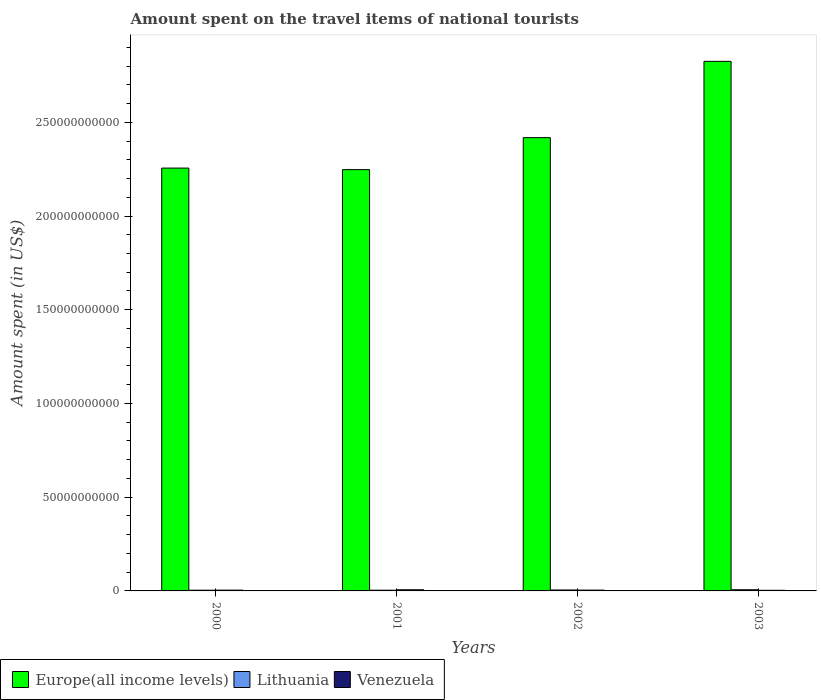How many bars are there on the 2nd tick from the left?
Provide a succinct answer. 3. How many bars are there on the 2nd tick from the right?
Your answer should be compact. 3. What is the label of the 1st group of bars from the left?
Your answer should be compact. 2000. What is the amount spent on the travel items of national tourists in Venezuela in 2002?
Ensure brevity in your answer.  4.34e+08. Across all years, what is the maximum amount spent on the travel items of national tourists in Europe(all income levels)?
Make the answer very short. 2.83e+11. Across all years, what is the minimum amount spent on the travel items of national tourists in Europe(all income levels)?
Provide a succinct answer. 2.25e+11. In which year was the amount spent on the travel items of national tourists in Europe(all income levels) maximum?
Keep it short and to the point. 2003. What is the total amount spent on the travel items of national tourists in Venezuela in the graph?
Provide a succinct answer. 1.80e+09. What is the difference between the amount spent on the travel items of national tourists in Europe(all income levels) in 2001 and that in 2002?
Ensure brevity in your answer.  -1.71e+1. What is the difference between the amount spent on the travel items of national tourists in Lithuania in 2001 and the amount spent on the travel items of national tourists in Venezuela in 2002?
Offer a very short reply. -5.10e+07. What is the average amount spent on the travel items of national tourists in Europe(all income levels) per year?
Make the answer very short. 2.44e+11. In the year 2000, what is the difference between the amount spent on the travel items of national tourists in Lithuania and amount spent on the travel items of national tourists in Europe(all income levels)?
Your response must be concise. -2.25e+11. What is the ratio of the amount spent on the travel items of national tourists in Venezuela in 2002 to that in 2003?
Provide a succinct answer. 1.31. Is the amount spent on the travel items of national tourists in Lithuania in 2001 less than that in 2002?
Give a very brief answer. Yes. Is the difference between the amount spent on the travel items of national tourists in Lithuania in 2002 and 2003 greater than the difference between the amount spent on the travel items of national tourists in Europe(all income levels) in 2002 and 2003?
Ensure brevity in your answer.  Yes. What is the difference between the highest and the second highest amount spent on the travel items of national tourists in Lithuania?
Your answer should be compact. 1.33e+08. What is the difference between the highest and the lowest amount spent on the travel items of national tourists in Europe(all income levels)?
Make the answer very short. 5.78e+1. Is the sum of the amount spent on the travel items of national tourists in Lithuania in 2001 and 2003 greater than the maximum amount spent on the travel items of national tourists in Europe(all income levels) across all years?
Your response must be concise. No. What does the 3rd bar from the left in 2000 represents?
Provide a succinct answer. Venezuela. What does the 3rd bar from the right in 2000 represents?
Keep it short and to the point. Europe(all income levels). How many bars are there?
Offer a very short reply. 12. How many years are there in the graph?
Provide a succinct answer. 4. Are the values on the major ticks of Y-axis written in scientific E-notation?
Keep it short and to the point. No. How many legend labels are there?
Your answer should be very brief. 3. What is the title of the graph?
Make the answer very short. Amount spent on the travel items of national tourists. Does "France" appear as one of the legend labels in the graph?
Your answer should be compact. No. What is the label or title of the X-axis?
Make the answer very short. Years. What is the label or title of the Y-axis?
Keep it short and to the point. Amount spent (in US$). What is the Amount spent (in US$) in Europe(all income levels) in 2000?
Offer a terse response. 2.26e+11. What is the Amount spent (in US$) of Lithuania in 2000?
Your answer should be very brief. 3.91e+08. What is the Amount spent (in US$) of Venezuela in 2000?
Your answer should be compact. 4.23e+08. What is the Amount spent (in US$) in Europe(all income levels) in 2001?
Give a very brief answer. 2.25e+11. What is the Amount spent (in US$) of Lithuania in 2001?
Give a very brief answer. 3.83e+08. What is the Amount spent (in US$) of Venezuela in 2001?
Ensure brevity in your answer.  6.15e+08. What is the Amount spent (in US$) of Europe(all income levels) in 2002?
Offer a very short reply. 2.42e+11. What is the Amount spent (in US$) of Lithuania in 2002?
Offer a terse response. 5.05e+08. What is the Amount spent (in US$) of Venezuela in 2002?
Provide a succinct answer. 4.34e+08. What is the Amount spent (in US$) in Europe(all income levels) in 2003?
Give a very brief answer. 2.83e+11. What is the Amount spent (in US$) of Lithuania in 2003?
Make the answer very short. 6.38e+08. What is the Amount spent (in US$) of Venezuela in 2003?
Your answer should be compact. 3.31e+08. Across all years, what is the maximum Amount spent (in US$) in Europe(all income levels)?
Give a very brief answer. 2.83e+11. Across all years, what is the maximum Amount spent (in US$) in Lithuania?
Your answer should be very brief. 6.38e+08. Across all years, what is the maximum Amount spent (in US$) of Venezuela?
Make the answer very short. 6.15e+08. Across all years, what is the minimum Amount spent (in US$) in Europe(all income levels)?
Offer a terse response. 2.25e+11. Across all years, what is the minimum Amount spent (in US$) of Lithuania?
Ensure brevity in your answer.  3.83e+08. Across all years, what is the minimum Amount spent (in US$) in Venezuela?
Your answer should be very brief. 3.31e+08. What is the total Amount spent (in US$) of Europe(all income levels) in the graph?
Offer a terse response. 9.75e+11. What is the total Amount spent (in US$) of Lithuania in the graph?
Provide a short and direct response. 1.92e+09. What is the total Amount spent (in US$) in Venezuela in the graph?
Your answer should be compact. 1.80e+09. What is the difference between the Amount spent (in US$) of Europe(all income levels) in 2000 and that in 2001?
Ensure brevity in your answer.  8.29e+08. What is the difference between the Amount spent (in US$) in Lithuania in 2000 and that in 2001?
Your answer should be very brief. 8.00e+06. What is the difference between the Amount spent (in US$) of Venezuela in 2000 and that in 2001?
Offer a very short reply. -1.92e+08. What is the difference between the Amount spent (in US$) of Europe(all income levels) in 2000 and that in 2002?
Provide a short and direct response. -1.62e+1. What is the difference between the Amount spent (in US$) in Lithuania in 2000 and that in 2002?
Offer a terse response. -1.14e+08. What is the difference between the Amount spent (in US$) of Venezuela in 2000 and that in 2002?
Give a very brief answer. -1.10e+07. What is the difference between the Amount spent (in US$) in Europe(all income levels) in 2000 and that in 2003?
Make the answer very short. -5.69e+1. What is the difference between the Amount spent (in US$) of Lithuania in 2000 and that in 2003?
Offer a very short reply. -2.47e+08. What is the difference between the Amount spent (in US$) in Venezuela in 2000 and that in 2003?
Your response must be concise. 9.20e+07. What is the difference between the Amount spent (in US$) in Europe(all income levels) in 2001 and that in 2002?
Keep it short and to the point. -1.71e+1. What is the difference between the Amount spent (in US$) in Lithuania in 2001 and that in 2002?
Give a very brief answer. -1.22e+08. What is the difference between the Amount spent (in US$) of Venezuela in 2001 and that in 2002?
Provide a short and direct response. 1.81e+08. What is the difference between the Amount spent (in US$) of Europe(all income levels) in 2001 and that in 2003?
Your answer should be compact. -5.78e+1. What is the difference between the Amount spent (in US$) of Lithuania in 2001 and that in 2003?
Your answer should be compact. -2.55e+08. What is the difference between the Amount spent (in US$) in Venezuela in 2001 and that in 2003?
Offer a terse response. 2.84e+08. What is the difference between the Amount spent (in US$) in Europe(all income levels) in 2002 and that in 2003?
Provide a short and direct response. -4.07e+1. What is the difference between the Amount spent (in US$) in Lithuania in 2002 and that in 2003?
Your response must be concise. -1.33e+08. What is the difference between the Amount spent (in US$) in Venezuela in 2002 and that in 2003?
Provide a succinct answer. 1.03e+08. What is the difference between the Amount spent (in US$) of Europe(all income levels) in 2000 and the Amount spent (in US$) of Lithuania in 2001?
Offer a very short reply. 2.25e+11. What is the difference between the Amount spent (in US$) of Europe(all income levels) in 2000 and the Amount spent (in US$) of Venezuela in 2001?
Give a very brief answer. 2.25e+11. What is the difference between the Amount spent (in US$) in Lithuania in 2000 and the Amount spent (in US$) in Venezuela in 2001?
Give a very brief answer. -2.24e+08. What is the difference between the Amount spent (in US$) in Europe(all income levels) in 2000 and the Amount spent (in US$) in Lithuania in 2002?
Give a very brief answer. 2.25e+11. What is the difference between the Amount spent (in US$) in Europe(all income levels) in 2000 and the Amount spent (in US$) in Venezuela in 2002?
Provide a succinct answer. 2.25e+11. What is the difference between the Amount spent (in US$) in Lithuania in 2000 and the Amount spent (in US$) in Venezuela in 2002?
Provide a succinct answer. -4.30e+07. What is the difference between the Amount spent (in US$) of Europe(all income levels) in 2000 and the Amount spent (in US$) of Lithuania in 2003?
Make the answer very short. 2.25e+11. What is the difference between the Amount spent (in US$) of Europe(all income levels) in 2000 and the Amount spent (in US$) of Venezuela in 2003?
Your answer should be very brief. 2.25e+11. What is the difference between the Amount spent (in US$) of Lithuania in 2000 and the Amount spent (in US$) of Venezuela in 2003?
Keep it short and to the point. 6.00e+07. What is the difference between the Amount spent (in US$) of Europe(all income levels) in 2001 and the Amount spent (in US$) of Lithuania in 2002?
Keep it short and to the point. 2.24e+11. What is the difference between the Amount spent (in US$) in Europe(all income levels) in 2001 and the Amount spent (in US$) in Venezuela in 2002?
Your answer should be very brief. 2.24e+11. What is the difference between the Amount spent (in US$) of Lithuania in 2001 and the Amount spent (in US$) of Venezuela in 2002?
Make the answer very short. -5.10e+07. What is the difference between the Amount spent (in US$) in Europe(all income levels) in 2001 and the Amount spent (in US$) in Lithuania in 2003?
Your answer should be very brief. 2.24e+11. What is the difference between the Amount spent (in US$) in Europe(all income levels) in 2001 and the Amount spent (in US$) in Venezuela in 2003?
Provide a short and direct response. 2.24e+11. What is the difference between the Amount spent (in US$) of Lithuania in 2001 and the Amount spent (in US$) of Venezuela in 2003?
Make the answer very short. 5.20e+07. What is the difference between the Amount spent (in US$) in Europe(all income levels) in 2002 and the Amount spent (in US$) in Lithuania in 2003?
Provide a succinct answer. 2.41e+11. What is the difference between the Amount spent (in US$) in Europe(all income levels) in 2002 and the Amount spent (in US$) in Venezuela in 2003?
Your response must be concise. 2.41e+11. What is the difference between the Amount spent (in US$) of Lithuania in 2002 and the Amount spent (in US$) of Venezuela in 2003?
Ensure brevity in your answer.  1.74e+08. What is the average Amount spent (in US$) in Europe(all income levels) per year?
Offer a very short reply. 2.44e+11. What is the average Amount spent (in US$) in Lithuania per year?
Your answer should be very brief. 4.79e+08. What is the average Amount spent (in US$) in Venezuela per year?
Provide a short and direct response. 4.51e+08. In the year 2000, what is the difference between the Amount spent (in US$) of Europe(all income levels) and Amount spent (in US$) of Lithuania?
Offer a terse response. 2.25e+11. In the year 2000, what is the difference between the Amount spent (in US$) of Europe(all income levels) and Amount spent (in US$) of Venezuela?
Your response must be concise. 2.25e+11. In the year 2000, what is the difference between the Amount spent (in US$) of Lithuania and Amount spent (in US$) of Venezuela?
Offer a very short reply. -3.20e+07. In the year 2001, what is the difference between the Amount spent (in US$) of Europe(all income levels) and Amount spent (in US$) of Lithuania?
Provide a succinct answer. 2.24e+11. In the year 2001, what is the difference between the Amount spent (in US$) of Europe(all income levels) and Amount spent (in US$) of Venezuela?
Provide a succinct answer. 2.24e+11. In the year 2001, what is the difference between the Amount spent (in US$) of Lithuania and Amount spent (in US$) of Venezuela?
Give a very brief answer. -2.32e+08. In the year 2002, what is the difference between the Amount spent (in US$) of Europe(all income levels) and Amount spent (in US$) of Lithuania?
Ensure brevity in your answer.  2.41e+11. In the year 2002, what is the difference between the Amount spent (in US$) of Europe(all income levels) and Amount spent (in US$) of Venezuela?
Your response must be concise. 2.41e+11. In the year 2002, what is the difference between the Amount spent (in US$) in Lithuania and Amount spent (in US$) in Venezuela?
Offer a very short reply. 7.10e+07. In the year 2003, what is the difference between the Amount spent (in US$) of Europe(all income levels) and Amount spent (in US$) of Lithuania?
Give a very brief answer. 2.82e+11. In the year 2003, what is the difference between the Amount spent (in US$) in Europe(all income levels) and Amount spent (in US$) in Venezuela?
Ensure brevity in your answer.  2.82e+11. In the year 2003, what is the difference between the Amount spent (in US$) in Lithuania and Amount spent (in US$) in Venezuela?
Your answer should be compact. 3.07e+08. What is the ratio of the Amount spent (in US$) in Europe(all income levels) in 2000 to that in 2001?
Your answer should be very brief. 1. What is the ratio of the Amount spent (in US$) of Lithuania in 2000 to that in 2001?
Offer a very short reply. 1.02. What is the ratio of the Amount spent (in US$) in Venezuela in 2000 to that in 2001?
Provide a short and direct response. 0.69. What is the ratio of the Amount spent (in US$) in Europe(all income levels) in 2000 to that in 2002?
Keep it short and to the point. 0.93. What is the ratio of the Amount spent (in US$) of Lithuania in 2000 to that in 2002?
Your answer should be very brief. 0.77. What is the ratio of the Amount spent (in US$) of Venezuela in 2000 to that in 2002?
Your answer should be very brief. 0.97. What is the ratio of the Amount spent (in US$) in Europe(all income levels) in 2000 to that in 2003?
Keep it short and to the point. 0.8. What is the ratio of the Amount spent (in US$) of Lithuania in 2000 to that in 2003?
Keep it short and to the point. 0.61. What is the ratio of the Amount spent (in US$) of Venezuela in 2000 to that in 2003?
Your response must be concise. 1.28. What is the ratio of the Amount spent (in US$) of Europe(all income levels) in 2001 to that in 2002?
Provide a succinct answer. 0.93. What is the ratio of the Amount spent (in US$) of Lithuania in 2001 to that in 2002?
Offer a very short reply. 0.76. What is the ratio of the Amount spent (in US$) in Venezuela in 2001 to that in 2002?
Your response must be concise. 1.42. What is the ratio of the Amount spent (in US$) in Europe(all income levels) in 2001 to that in 2003?
Your response must be concise. 0.8. What is the ratio of the Amount spent (in US$) in Lithuania in 2001 to that in 2003?
Keep it short and to the point. 0.6. What is the ratio of the Amount spent (in US$) in Venezuela in 2001 to that in 2003?
Your answer should be compact. 1.86. What is the ratio of the Amount spent (in US$) of Europe(all income levels) in 2002 to that in 2003?
Make the answer very short. 0.86. What is the ratio of the Amount spent (in US$) of Lithuania in 2002 to that in 2003?
Give a very brief answer. 0.79. What is the ratio of the Amount spent (in US$) in Venezuela in 2002 to that in 2003?
Provide a succinct answer. 1.31. What is the difference between the highest and the second highest Amount spent (in US$) in Europe(all income levels)?
Provide a short and direct response. 4.07e+1. What is the difference between the highest and the second highest Amount spent (in US$) in Lithuania?
Provide a short and direct response. 1.33e+08. What is the difference between the highest and the second highest Amount spent (in US$) of Venezuela?
Give a very brief answer. 1.81e+08. What is the difference between the highest and the lowest Amount spent (in US$) of Europe(all income levels)?
Provide a short and direct response. 5.78e+1. What is the difference between the highest and the lowest Amount spent (in US$) in Lithuania?
Make the answer very short. 2.55e+08. What is the difference between the highest and the lowest Amount spent (in US$) in Venezuela?
Keep it short and to the point. 2.84e+08. 